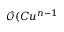Convert formula to latex. <formula><loc_0><loc_0><loc_500><loc_500>\mathcal { O } ( C u ^ { n - 1 }</formula> 